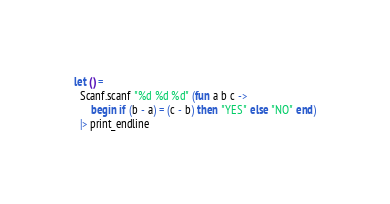<code> <loc_0><loc_0><loc_500><loc_500><_OCaml_>let () =
  Scanf.scanf "%d %d %d" (fun a b c ->
      begin if (b - a) = (c - b) then "YES" else "NO" end)
  |> print_endline</code> 